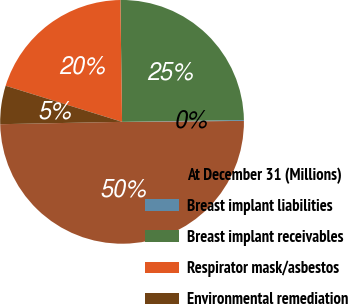Convert chart to OTSL. <chart><loc_0><loc_0><loc_500><loc_500><pie_chart><fcel>At December 31 (Millions)<fcel>Breast implant liabilities<fcel>Breast implant receivables<fcel>Respirator mask/asbestos<fcel>Environmental remediation<nl><fcel>49.81%<fcel>0.12%<fcel>24.97%<fcel>20.0%<fcel>5.09%<nl></chart> 